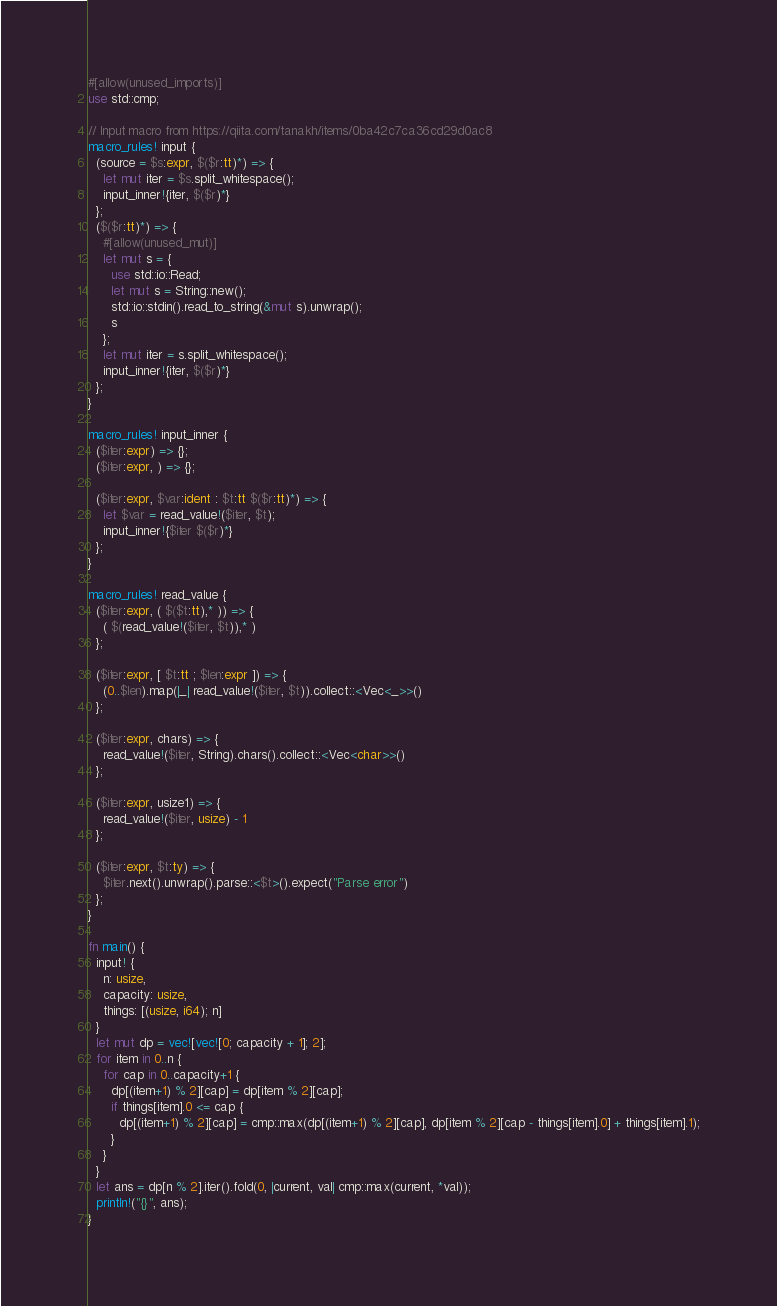Convert code to text. <code><loc_0><loc_0><loc_500><loc_500><_Rust_>#[allow(unused_imports)]
use std::cmp;

// Input macro from https://qiita.com/tanakh/items/0ba42c7ca36cd29d0ac8
macro_rules! input {
  (source = $s:expr, $($r:tt)*) => {
    let mut iter = $s.split_whitespace();
    input_inner!{iter, $($r)*}
  };
  ($($r:tt)*) => {
    #[allow(unused_mut)]
    let mut s = {
      use std::io::Read;
      let mut s = String::new();
      std::io::stdin().read_to_string(&mut s).unwrap();
      s
    };
    let mut iter = s.split_whitespace();
    input_inner!{iter, $($r)*}
  };
}

macro_rules! input_inner {
  ($iter:expr) => {};
  ($iter:expr, ) => {};

  ($iter:expr, $var:ident : $t:tt $($r:tt)*) => {
    let $var = read_value!($iter, $t);
    input_inner!{$iter $($r)*}
  };
}

macro_rules! read_value {
  ($iter:expr, ( $($t:tt),* )) => {
    ( $(read_value!($iter, $t)),* )
  };

  ($iter:expr, [ $t:tt ; $len:expr ]) => {
    (0..$len).map(|_| read_value!($iter, $t)).collect::<Vec<_>>()
  };

  ($iter:expr, chars) => {
    read_value!($iter, String).chars().collect::<Vec<char>>()
  };

  ($iter:expr, usize1) => {
    read_value!($iter, usize) - 1
  };

  ($iter:expr, $t:ty) => {
    $iter.next().unwrap().parse::<$t>().expect("Parse error")
  };
}

fn main() {
  input! {
    n: usize,
    capacity: usize,
    things: [(usize, i64); n]
  }
  let mut dp = vec![vec![0; capacity + 1]; 2];
  for item in 0..n {
    for cap in 0..capacity+1 {
      dp[(item+1) % 2][cap] = dp[item % 2][cap];
      if things[item].0 <= cap {
        dp[(item+1) % 2][cap] = cmp::max(dp[(item+1) % 2][cap], dp[item % 2][cap - things[item].0] + things[item].1);
      }
    }
  }
  let ans = dp[n % 2].iter().fold(0, |current, val| cmp::max(current, *val));
  println!("{}", ans);
}
</code> 